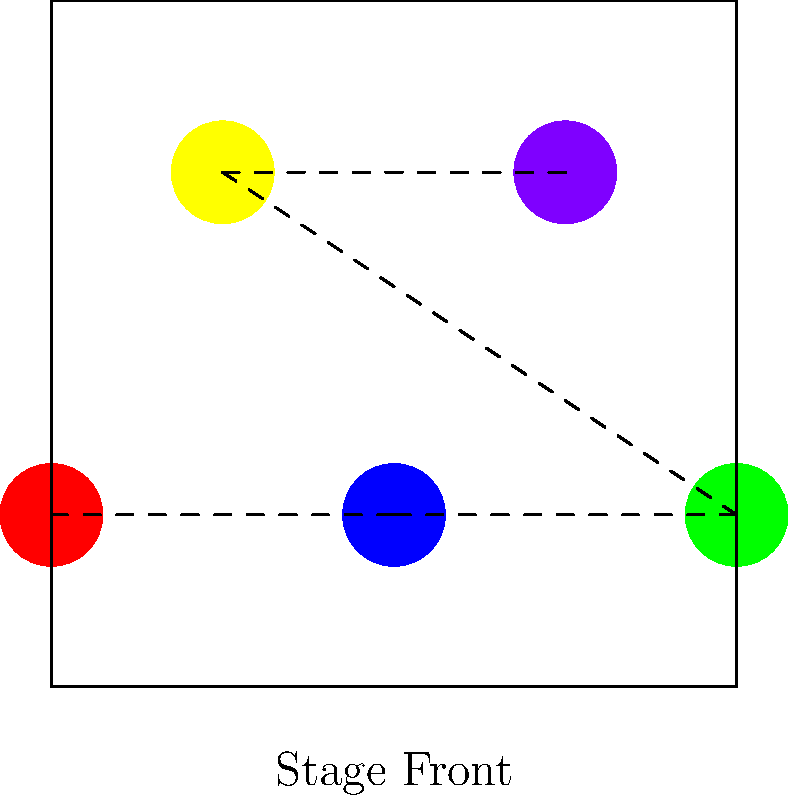In the given bird's-eye view diagram of a K-pop group's stage formation, what geometric shape is formed by connecting the positions of the members? To determine the geometric shape formed by connecting the positions of the members, let's follow these steps:

1. Identify the positions of the members:
   - There are 5 members represented by colored circles on the stage.

2. Connect the positions:
   - The dashed lines in the diagram connect the members' positions.

3. Analyze the resulting shape:
   - Starting from the left, we see three members in a straight line at the front of the stage.
   - Two more members are positioned behind the gaps between the front members.

4. Recognize the shape:
   - The resulting shape has 5 vertices (one for each member).
   - It has 4 sides (connecting adjacent members).
   - The shape is not closed, as there is no connection between the first and last member.

5. Conclude:
   - This open shape with 5 vertices and 4 sides forms a zigzag pattern.
   - In geometric terms, this is called a polyline or an open polygonal chain.

Therefore, the geometric shape formed by connecting the positions of the members is a polyline or an open polygonal chain, specifically in a zigzag pattern.
Answer: Polyline (or open polygonal chain) 